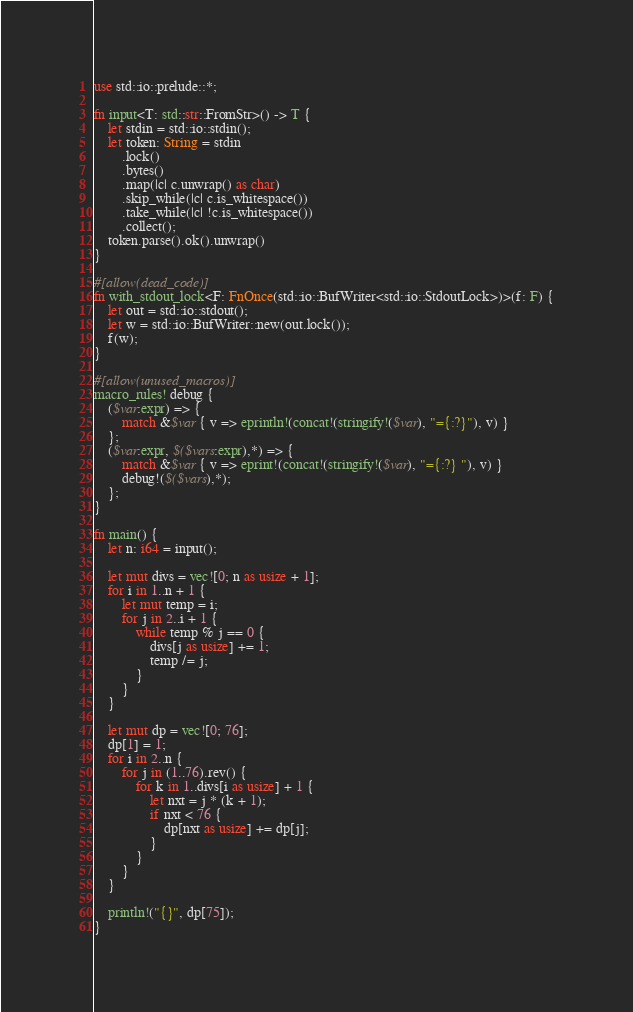Convert code to text. <code><loc_0><loc_0><loc_500><loc_500><_Rust_>use std::io::prelude::*;

fn input<T: std::str::FromStr>() -> T {
    let stdin = std::io::stdin();
    let token: String = stdin
        .lock()
        .bytes()
        .map(|c| c.unwrap() as char)
        .skip_while(|c| c.is_whitespace())
        .take_while(|c| !c.is_whitespace())
        .collect();
    token.parse().ok().unwrap()
}

#[allow(dead_code)]
fn with_stdout_lock<F: FnOnce(std::io::BufWriter<std::io::StdoutLock>)>(f: F) {
    let out = std::io::stdout();
    let w = std::io::BufWriter::new(out.lock());
    f(w);
}

#[allow(unused_macros)]
macro_rules! debug {
    ($var:expr) => {
        match &$var { v => eprintln!(concat!(stringify!($var), "={:?}"), v) }
    };
    ($var:expr, $($vars:expr),*) => {
        match &$var { v => eprint!(concat!(stringify!($var), "={:?} "), v) }
        debug!($($vars),*);
    };
}

fn main() {
    let n: i64 = input();

    let mut divs = vec![0; n as usize + 1];
    for i in 1..n + 1 {
        let mut temp = i;
        for j in 2..i + 1 {
            while temp % j == 0 {
                divs[j as usize] += 1;
                temp /= j;
            }
        }
    }

    let mut dp = vec![0; 76];
    dp[1] = 1;
    for i in 2..n {
        for j in (1..76).rev() {
            for k in 1..divs[i as usize] + 1 {
                let nxt = j * (k + 1);
                if nxt < 76 {
                    dp[nxt as usize] += dp[j];
                }
            }
        }
    }

    println!("{}", dp[75]);
}
</code> 